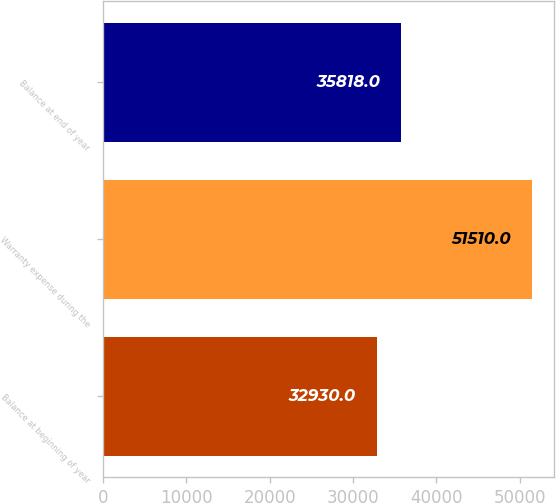<chart> <loc_0><loc_0><loc_500><loc_500><bar_chart><fcel>Balance at beginning of year<fcel>Warranty expense during the<fcel>Balance at end of year<nl><fcel>32930<fcel>51510<fcel>35818<nl></chart> 